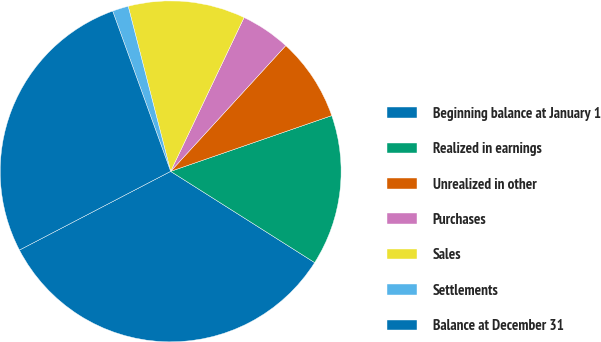Convert chart to OTSL. <chart><loc_0><loc_0><loc_500><loc_500><pie_chart><fcel>Beginning balance at January 1<fcel>Realized in earnings<fcel>Unrealized in other<fcel>Purchases<fcel>Sales<fcel>Settlements<fcel>Balance at December 31<nl><fcel>33.37%<fcel>14.29%<fcel>7.9%<fcel>4.71%<fcel>11.09%<fcel>1.52%<fcel>27.11%<nl></chart> 